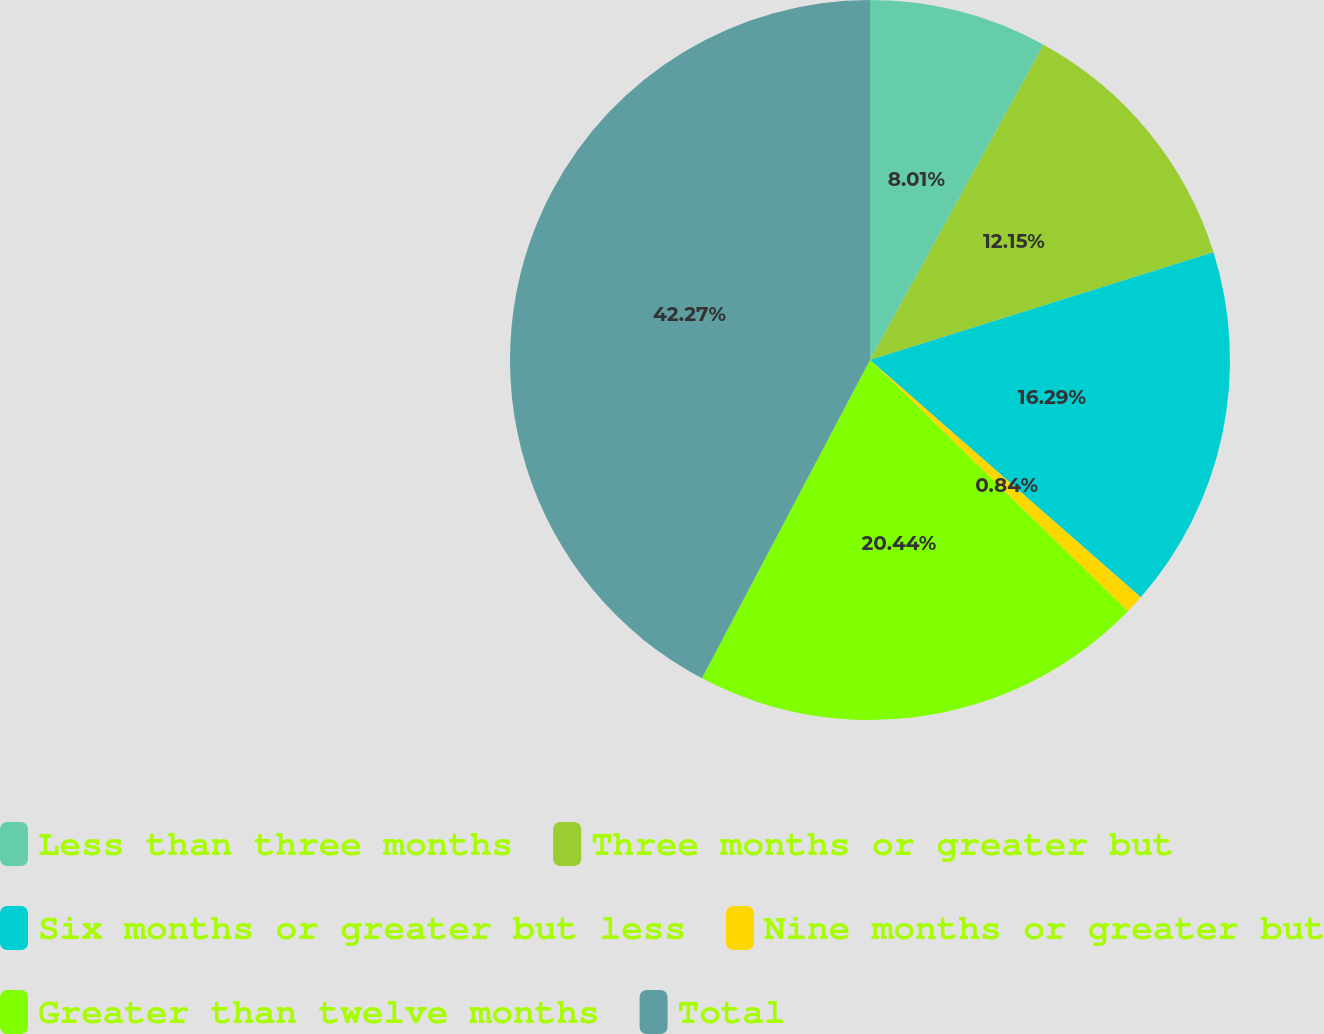<chart> <loc_0><loc_0><loc_500><loc_500><pie_chart><fcel>Less than three months<fcel>Three months or greater but<fcel>Six months or greater but less<fcel>Nine months or greater but<fcel>Greater than twelve months<fcel>Total<nl><fcel>8.01%<fcel>12.15%<fcel>16.29%<fcel>0.84%<fcel>20.44%<fcel>42.27%<nl></chart> 